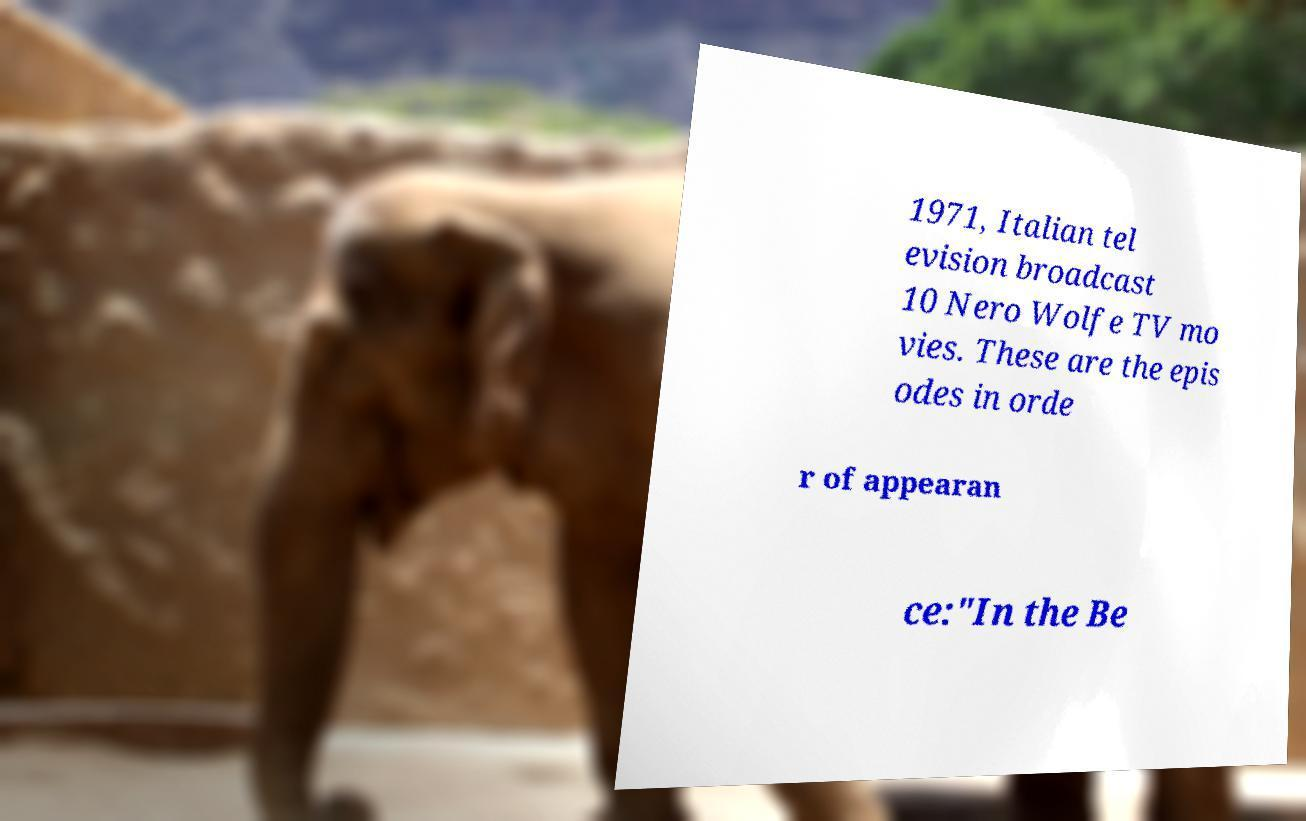For documentation purposes, I need the text within this image transcribed. Could you provide that? 1971, Italian tel evision broadcast 10 Nero Wolfe TV mo vies. These are the epis odes in orde r of appearan ce:"In the Be 